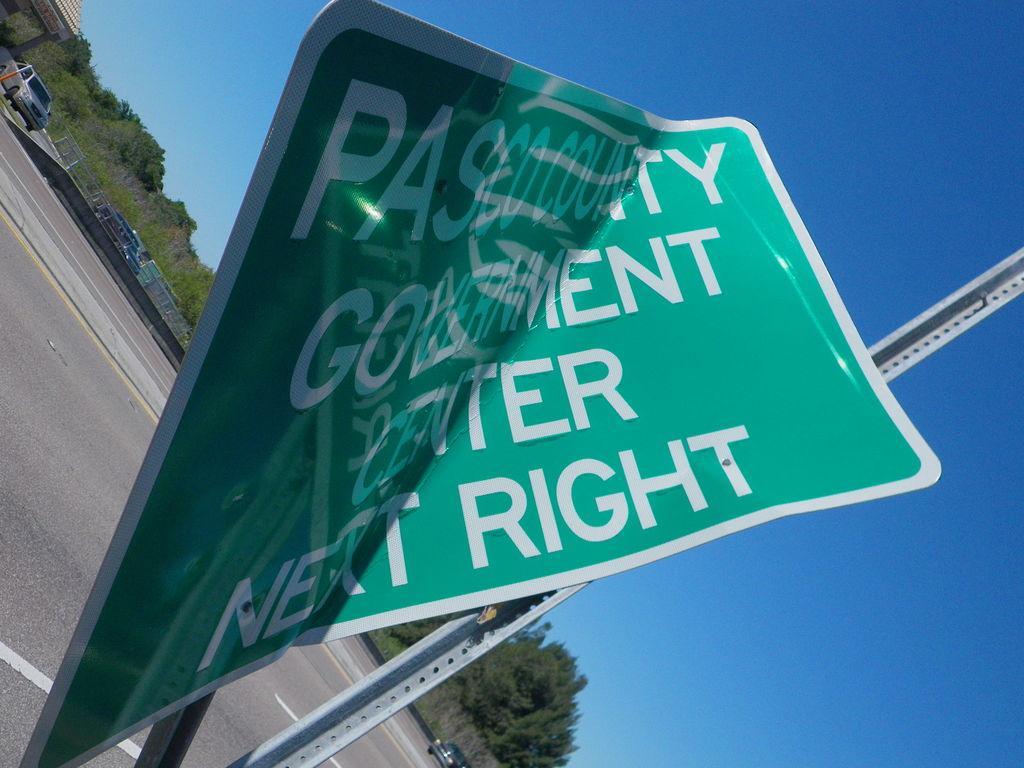Can you describe this image briefly? This is an outside view. Here I can see a board on which there is some text and there is a metal pole. In the background there are few vehicles on the road and many trees. At the top of the image I can see the sky in blue color. 